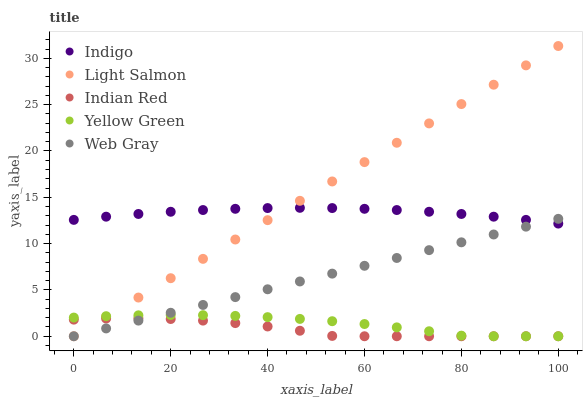Does Indian Red have the minimum area under the curve?
Answer yes or no. Yes. Does Light Salmon have the maximum area under the curve?
Answer yes or no. Yes. Does Web Gray have the minimum area under the curve?
Answer yes or no. No. Does Web Gray have the maximum area under the curve?
Answer yes or no. No. Is Web Gray the smoothest?
Answer yes or no. Yes. Is Indian Red the roughest?
Answer yes or no. Yes. Is Indigo the smoothest?
Answer yes or no. No. Is Indigo the roughest?
Answer yes or no. No. Does Light Salmon have the lowest value?
Answer yes or no. Yes. Does Indigo have the lowest value?
Answer yes or no. No. Does Light Salmon have the highest value?
Answer yes or no. Yes. Does Web Gray have the highest value?
Answer yes or no. No. Is Indian Red less than Indigo?
Answer yes or no. Yes. Is Indigo greater than Yellow Green?
Answer yes or no. Yes. Does Yellow Green intersect Light Salmon?
Answer yes or no. Yes. Is Yellow Green less than Light Salmon?
Answer yes or no. No. Is Yellow Green greater than Light Salmon?
Answer yes or no. No. Does Indian Red intersect Indigo?
Answer yes or no. No. 